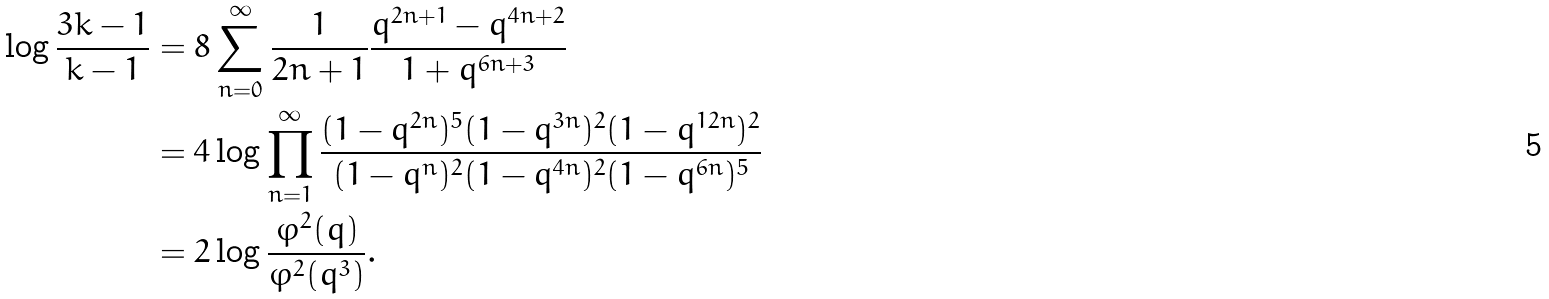<formula> <loc_0><loc_0><loc_500><loc_500>\log \frac { 3 k - 1 } { k - 1 } & = 8 \sum _ { n = 0 } ^ { \infty } \frac { 1 } { 2 n + 1 } \frac { q ^ { 2 n + 1 } - q ^ { 4 n + 2 } } { 1 + q ^ { 6 n + 3 } } \\ & = 4 \log \prod _ { n = 1 } ^ { \infty } \frac { ( 1 - q ^ { 2 n } ) ^ { 5 } ( 1 - q ^ { 3 n } ) ^ { 2 } ( 1 - q ^ { 1 2 n } ) ^ { 2 } } { ( 1 - q ^ { n } ) ^ { 2 } ( 1 - q ^ { 4 n } ) ^ { 2 } ( 1 - q ^ { 6 n } ) ^ { 5 } } \\ & = 2 \log \frac { \varphi ^ { 2 } ( q ) } { \varphi ^ { 2 } ( q ^ { 3 } ) } .</formula> 